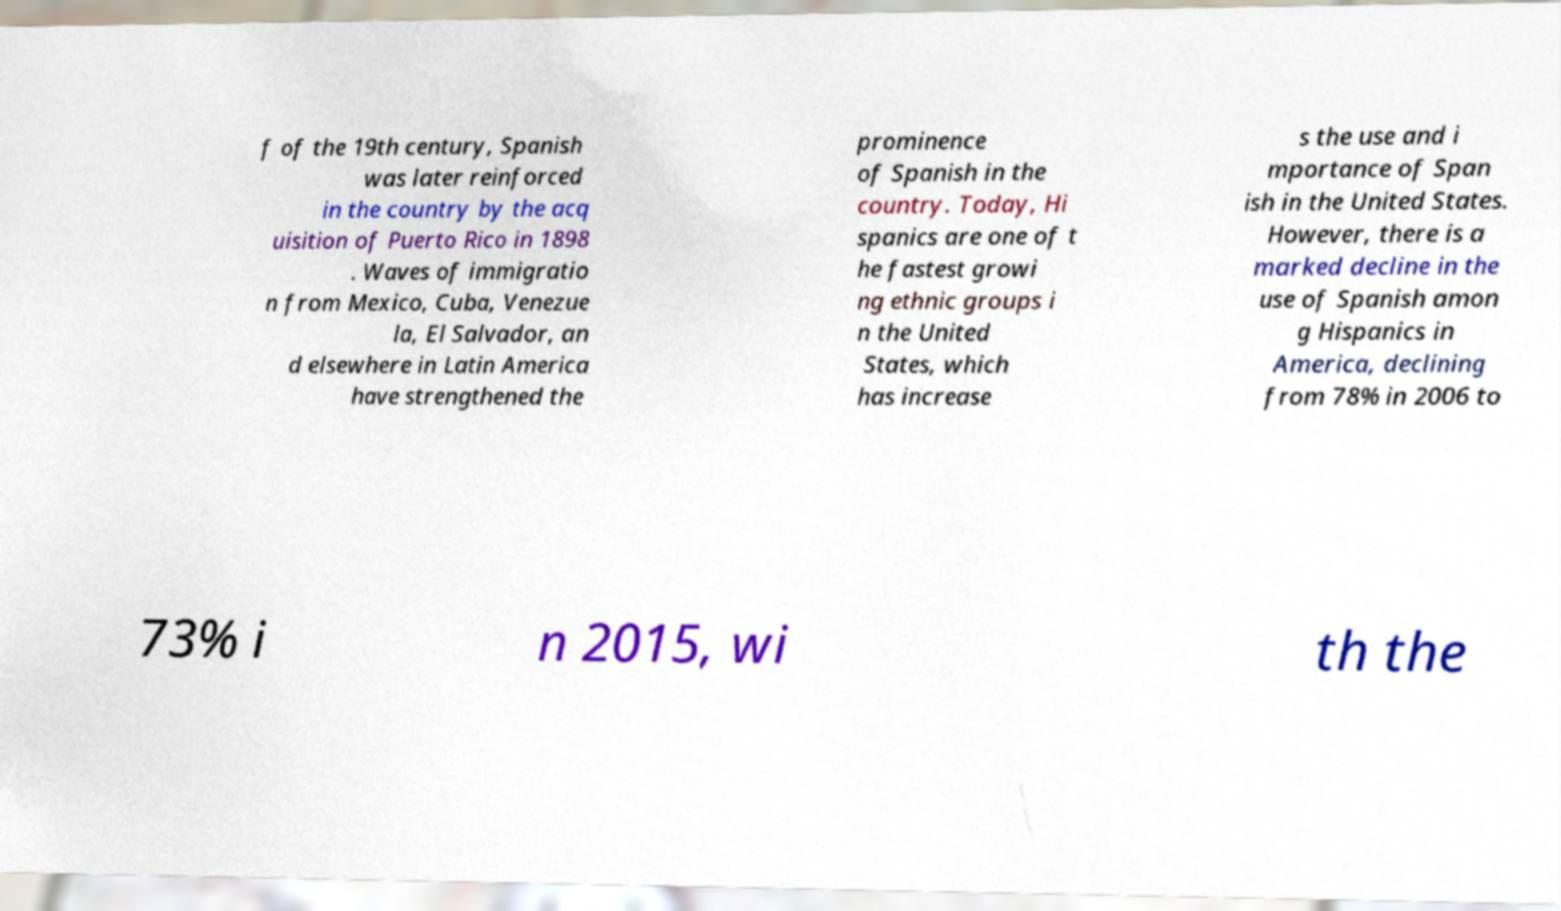Please identify and transcribe the text found in this image. f of the 19th century, Spanish was later reinforced in the country by the acq uisition of Puerto Rico in 1898 . Waves of immigratio n from Mexico, Cuba, Venezue la, El Salvador, an d elsewhere in Latin America have strengthened the prominence of Spanish in the country. Today, Hi spanics are one of t he fastest growi ng ethnic groups i n the United States, which has increase s the use and i mportance of Span ish in the United States. However, there is a marked decline in the use of Spanish amon g Hispanics in America, declining from 78% in 2006 to 73% i n 2015, wi th the 